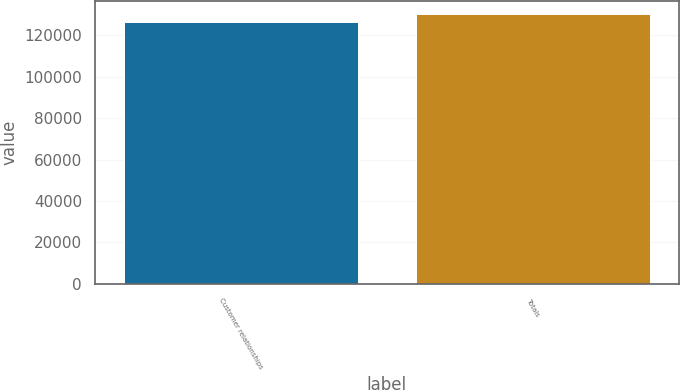<chart> <loc_0><loc_0><loc_500><loc_500><bar_chart><fcel>Customer relationships<fcel>Totals<nl><fcel>126244<fcel>130243<nl></chart> 